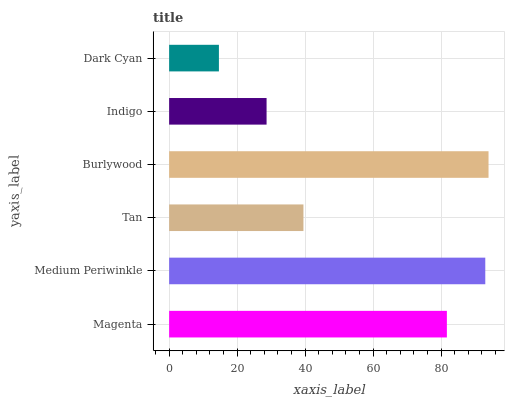Is Dark Cyan the minimum?
Answer yes or no. Yes. Is Burlywood the maximum?
Answer yes or no. Yes. Is Medium Periwinkle the minimum?
Answer yes or no. No. Is Medium Periwinkle the maximum?
Answer yes or no. No. Is Medium Periwinkle greater than Magenta?
Answer yes or no. Yes. Is Magenta less than Medium Periwinkle?
Answer yes or no. Yes. Is Magenta greater than Medium Periwinkle?
Answer yes or no. No. Is Medium Periwinkle less than Magenta?
Answer yes or no. No. Is Magenta the high median?
Answer yes or no. Yes. Is Tan the low median?
Answer yes or no. Yes. Is Tan the high median?
Answer yes or no. No. Is Burlywood the low median?
Answer yes or no. No. 